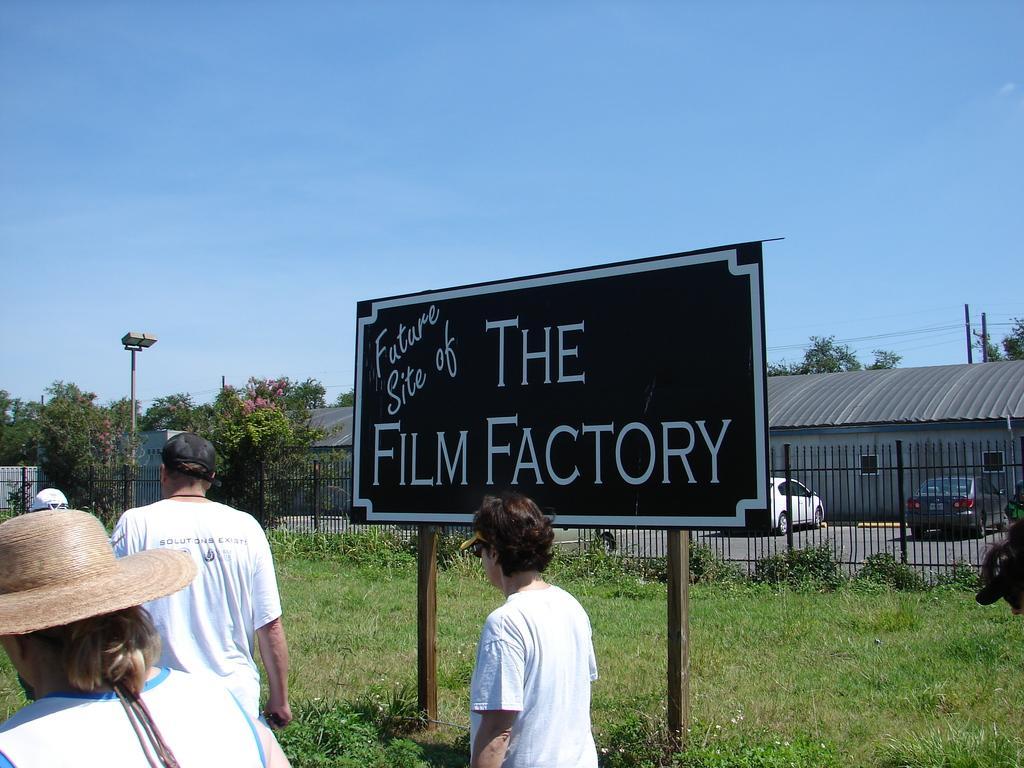Please provide a concise description of this image. In this image, we can see people and there are wearing caps. In the background, there are vehicles on the road and we can see railings, sheds, trees, poles along with wires and there is a board with some text. At the top, there is sky and at the bottom, there are plants on the ground. 